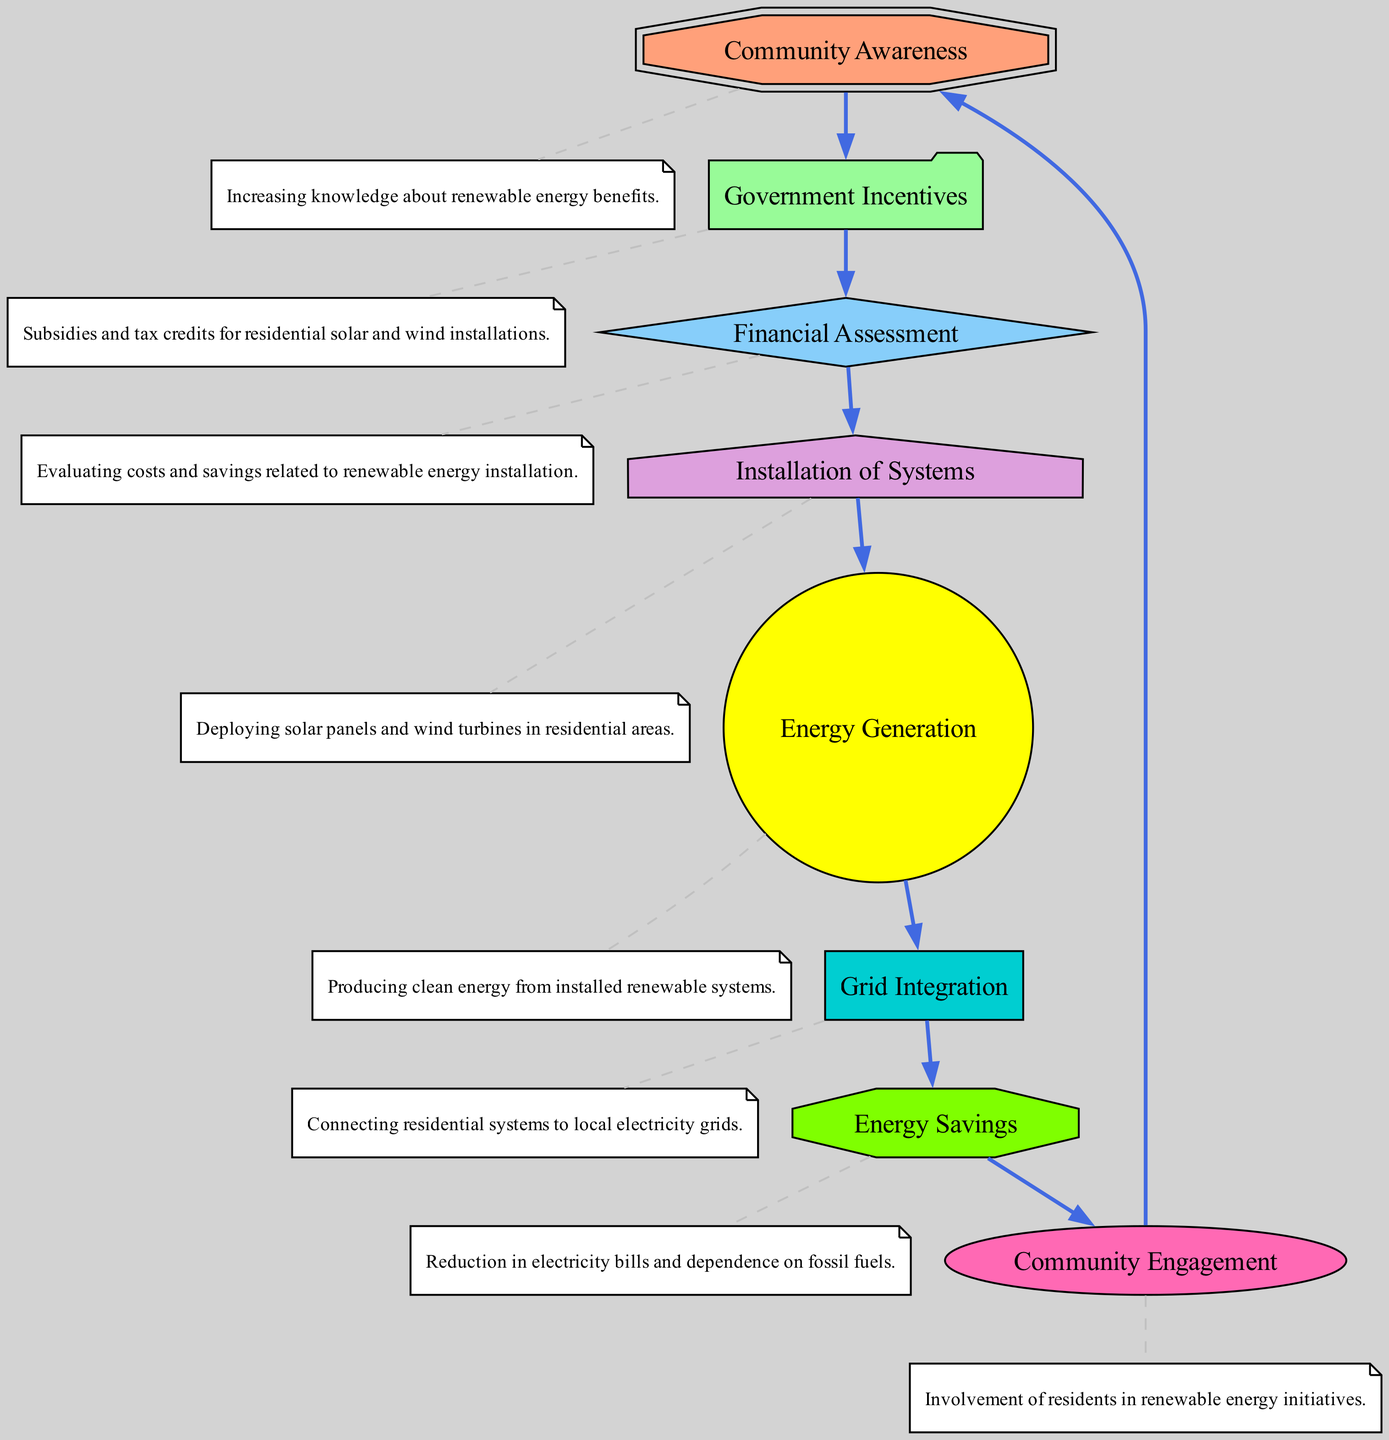What is the first node in the diagram? The first node in the diagram is "Community Awareness", which is where the process of renewable energy adoption begins.
Answer: Community Awareness How many total nodes are in the diagram? The diagram contains eight nodes that represent different aspects of renewable energy adoption in residential areas.
Answer: 8 What is the relationship between "Government Incentives" and "Financial Assessment"? "Government Incentives" directly leads to "Financial Assessment", indicating that incentives encourage evaluating the financial aspects of renewable energy.
Answer: Directly leads to What do residents achieve after "Grid Integration"? After "Grid Integration", residents benefit from "Energy Savings", which reflects the financial savings and reduced fossil fuel dependence from using renewable energy.
Answer: Energy Savings Which node leads to "Community Engagement"? "Energy Savings" leads to "Community Engagement", showcasing that savings motivate residents to get involved in renewable energy initiatives.
Answer: Energy Savings What shape is used for the "Installation of Systems" node? The "Installation of Systems" node is represented by a house shape, indicating its focus on the physical deployment of renewable energy systems in homes.
Answer: House How does "Community Awareness" influence the overall process? "Community Awareness" initiates the flow by increasing knowledge about renewable energy, which consequently affects all subsequent steps leading up to community engagement.
Answer: Initiates the flow What node follows "Energy Generation" in the flow? The node that follows "Energy Generation" is "Grid Integration", which indicates the step where generated energy is connected to the local electricity grid.
Answer: Grid Integration What is shown at the end of the flow in terms of community involvement? The end of the flow demonstrates "Community Engagement", highlighting that energy savings lead to increased participation in renewable energy initiatives by residents.
Answer: Community Engagement 